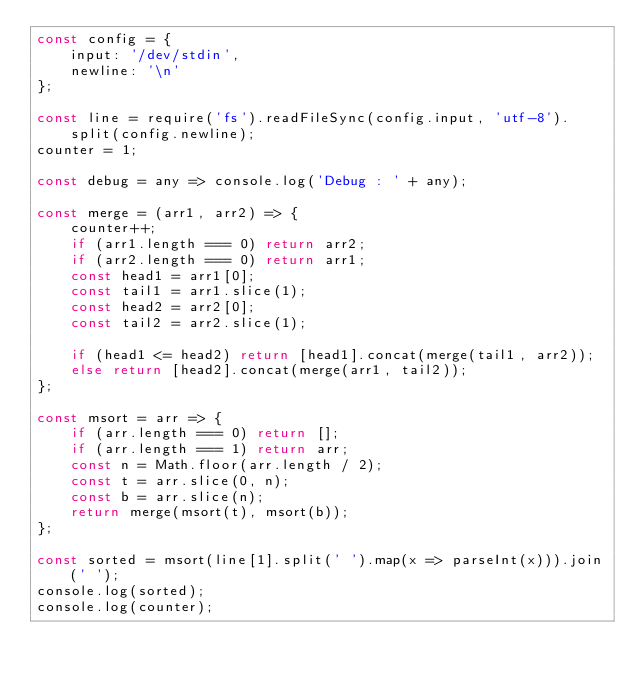<code> <loc_0><loc_0><loc_500><loc_500><_JavaScript_>const config = {
    input: '/dev/stdin',
    newline: '\n'
};

const line = require('fs').readFileSync(config.input, 'utf-8').split(config.newline);
counter = 1;

const debug = any => console.log('Debug : ' + any);

const merge = (arr1, arr2) => {
    counter++;
    if (arr1.length === 0) return arr2;
    if (arr2.length === 0) return arr1;
    const head1 = arr1[0];
    const tail1 = arr1.slice(1);
    const head2 = arr2[0];
    const tail2 = arr2.slice(1);

    if (head1 <= head2) return [head1].concat(merge(tail1, arr2));
    else return [head2].concat(merge(arr1, tail2));
};

const msort = arr => {
    if (arr.length === 0) return [];
    if (arr.length === 1) return arr;
    const n = Math.floor(arr.length / 2);
    const t = arr.slice(0, n);
    const b = arr.slice(n);
    return merge(msort(t), msort(b));
};

const sorted = msort(line[1].split(' ').map(x => parseInt(x))).join(' ');
console.log(sorted);
console.log(counter);

</code> 